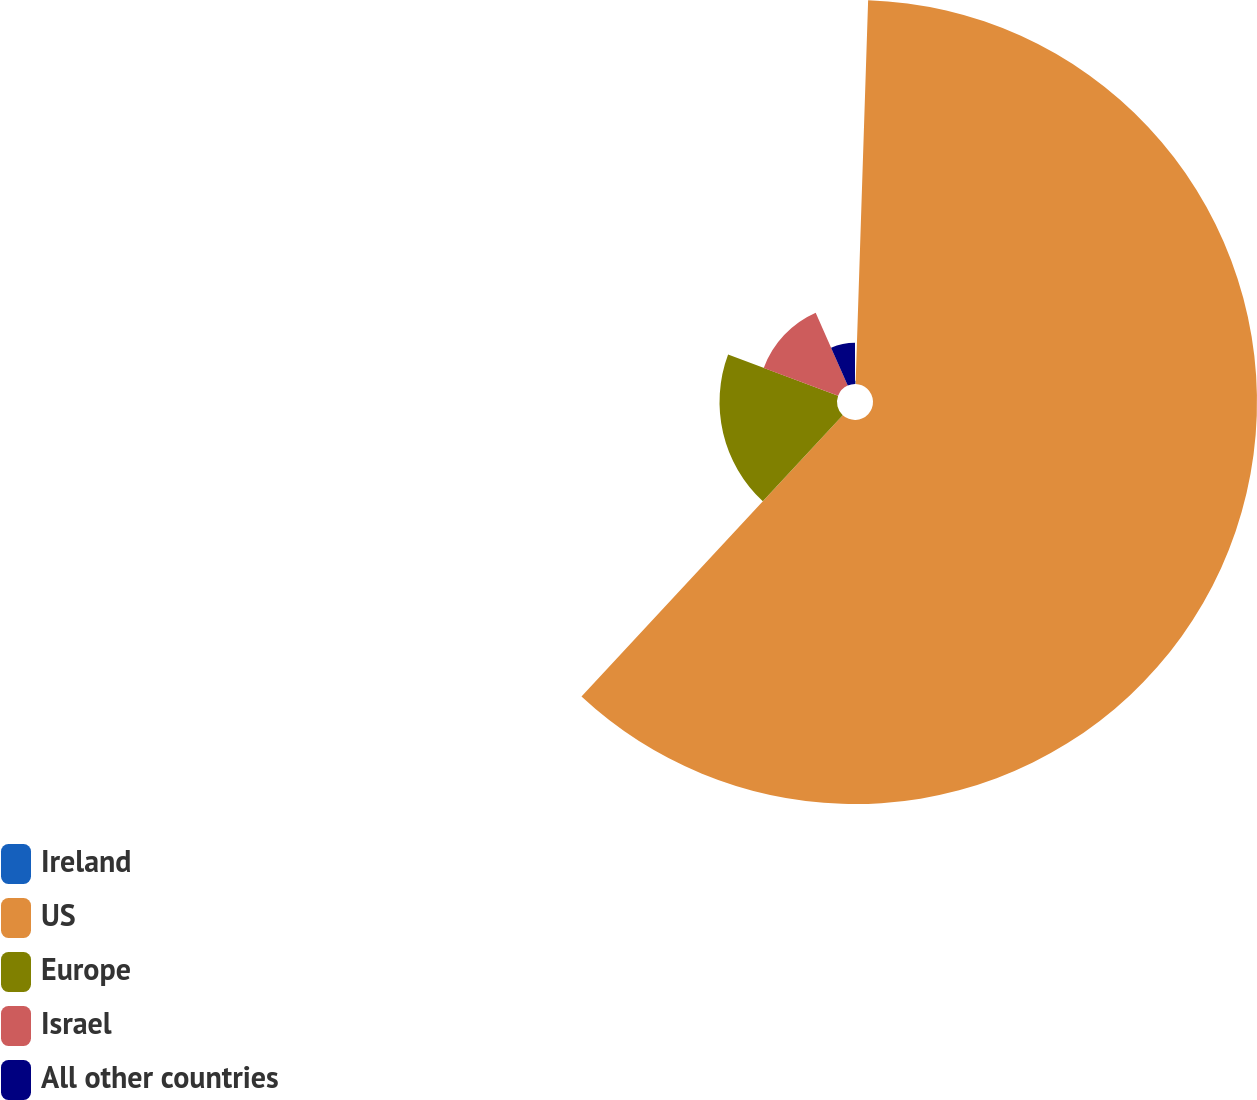Convert chart to OTSL. <chart><loc_0><loc_0><loc_500><loc_500><pie_chart><fcel>Ireland<fcel>US<fcel>Europe<fcel>Israel<fcel>All other countries<nl><fcel>0.52%<fcel>61.39%<fcel>18.78%<fcel>12.7%<fcel>6.61%<nl></chart> 